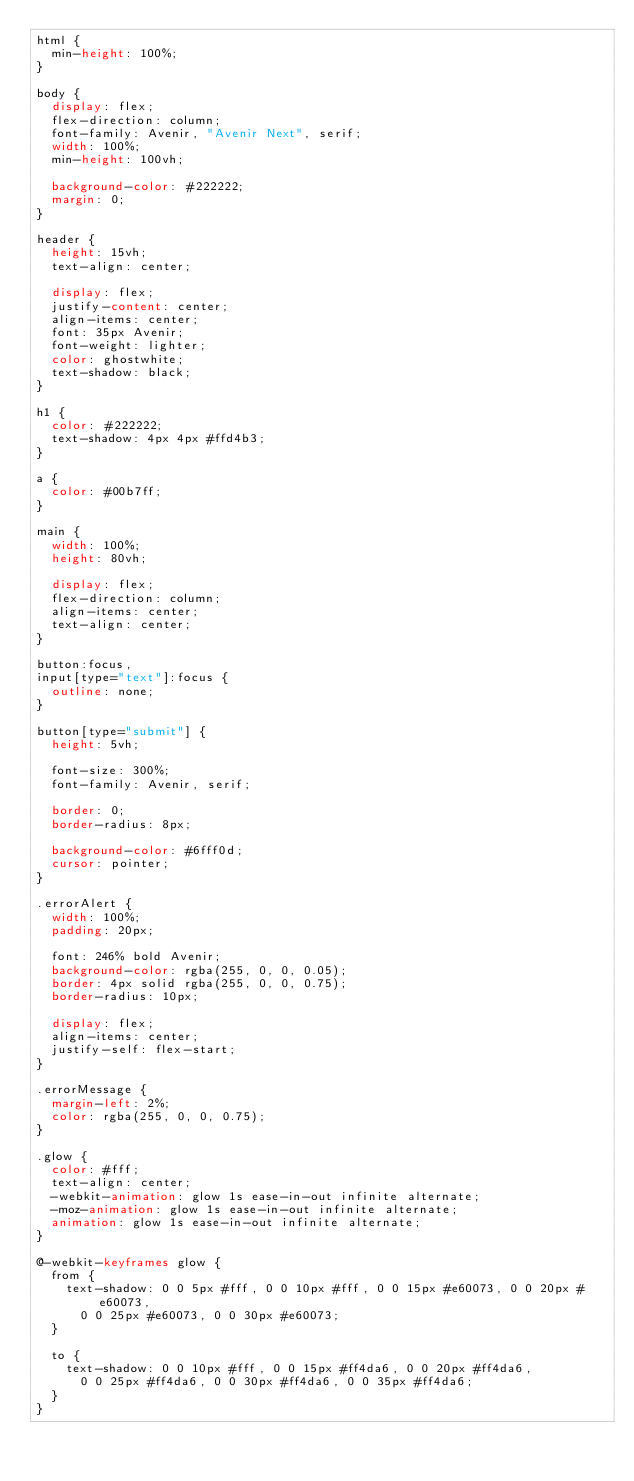Convert code to text. <code><loc_0><loc_0><loc_500><loc_500><_CSS_>html {
  min-height: 100%;
}

body {
  display: flex;
  flex-direction: column;
  font-family: Avenir, "Avenir Next", serif;
  width: 100%;
  min-height: 100vh;

  background-color: #222222;
  margin: 0;
}

header {
  height: 15vh;
  text-align: center;

  display: flex;
  justify-content: center;
  align-items: center;
  font: 35px Avenir;
  font-weight: lighter;
  color: ghostwhite;
  text-shadow: black;
}

h1 {
  color: #222222;
  text-shadow: 4px 4px #ffd4b3;
}

a {
  color: #00b7ff;
}

main {
  width: 100%;
  height: 80vh;

  display: flex;
  flex-direction: column;
  align-items: center;
  text-align: center;
}

button:focus,
input[type="text"]:focus {
  outline: none;
}

button[type="submit"] {
  height: 5vh;

  font-size: 300%;
  font-family: Avenir, serif;

  border: 0;
  border-radius: 8px;

  background-color: #6fff0d;
  cursor: pointer;
}

.errorAlert {
  width: 100%;
  padding: 20px;

  font: 246% bold Avenir;
  background-color: rgba(255, 0, 0, 0.05);
  border: 4px solid rgba(255, 0, 0, 0.75);
  border-radius: 10px;

  display: flex;
  align-items: center;
  justify-self: flex-start;
}

.errorMessage {
  margin-left: 2%;
  color: rgba(255, 0, 0, 0.75);
}

.glow {
  color: #fff;
  text-align: center;
  -webkit-animation: glow 1s ease-in-out infinite alternate;
  -moz-animation: glow 1s ease-in-out infinite alternate;
  animation: glow 1s ease-in-out infinite alternate;
}

@-webkit-keyframes glow {
  from {
    text-shadow: 0 0 5px #fff, 0 0 10px #fff, 0 0 15px #e60073, 0 0 20px #e60073,
      0 0 25px #e60073, 0 0 30px #e60073;
  }

  to {
    text-shadow: 0 0 10px #fff, 0 0 15px #ff4da6, 0 0 20px #ff4da6,
      0 0 25px #ff4da6, 0 0 30px #ff4da6, 0 0 35px #ff4da6;
  }
}
</code> 